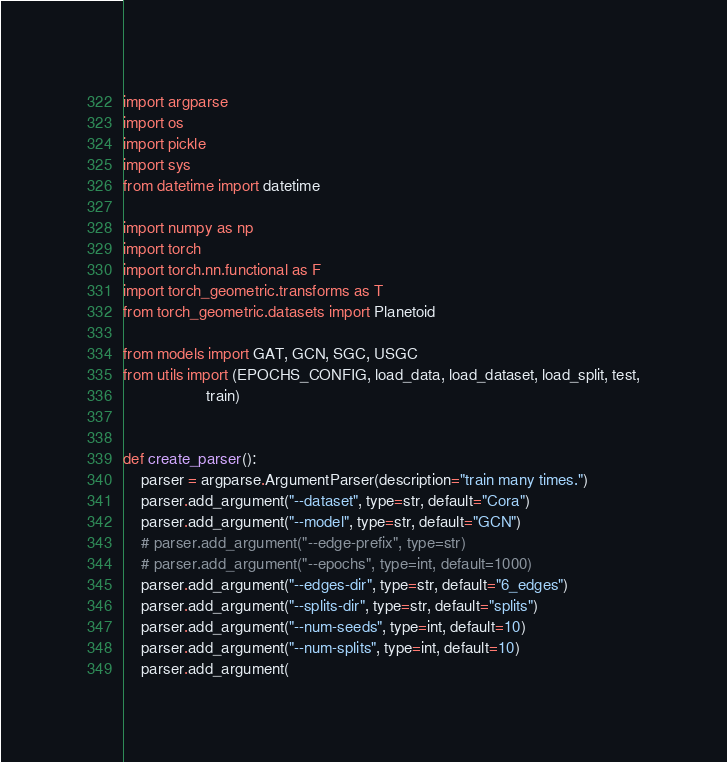Convert code to text. <code><loc_0><loc_0><loc_500><loc_500><_Python_>import argparse
import os
import pickle
import sys
from datetime import datetime

import numpy as np
import torch
import torch.nn.functional as F
import torch_geometric.transforms as T
from torch_geometric.datasets import Planetoid

from models import GAT, GCN, SGC, USGC
from utils import (EPOCHS_CONFIG, load_data, load_dataset, load_split, test,
                   train)


def create_parser():
    parser = argparse.ArgumentParser(description="train many times.")
    parser.add_argument("--dataset", type=str, default="Cora")
    parser.add_argument("--model", type=str, default="GCN")
    # parser.add_argument("--edge-prefix", type=str)
    # parser.add_argument("--epochs", type=int, default=1000)
    parser.add_argument("--edges-dir", type=str, default="6_edges")
    parser.add_argument("--splits-dir", type=str, default="splits")
    parser.add_argument("--num-seeds", type=int, default=10)
    parser.add_argument("--num-splits", type=int, default=10)
    parser.add_argument(</code> 